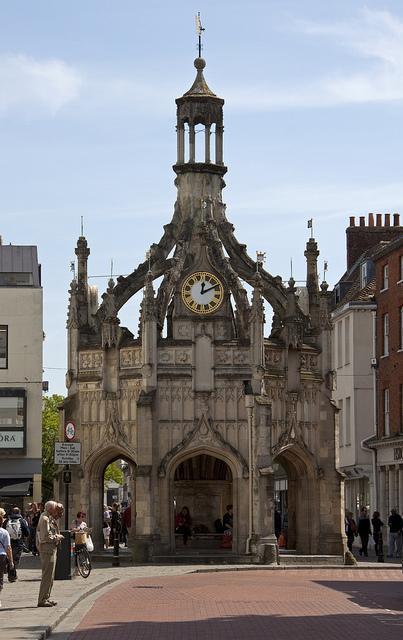How many boats do you see?
Give a very brief answer. 0. 